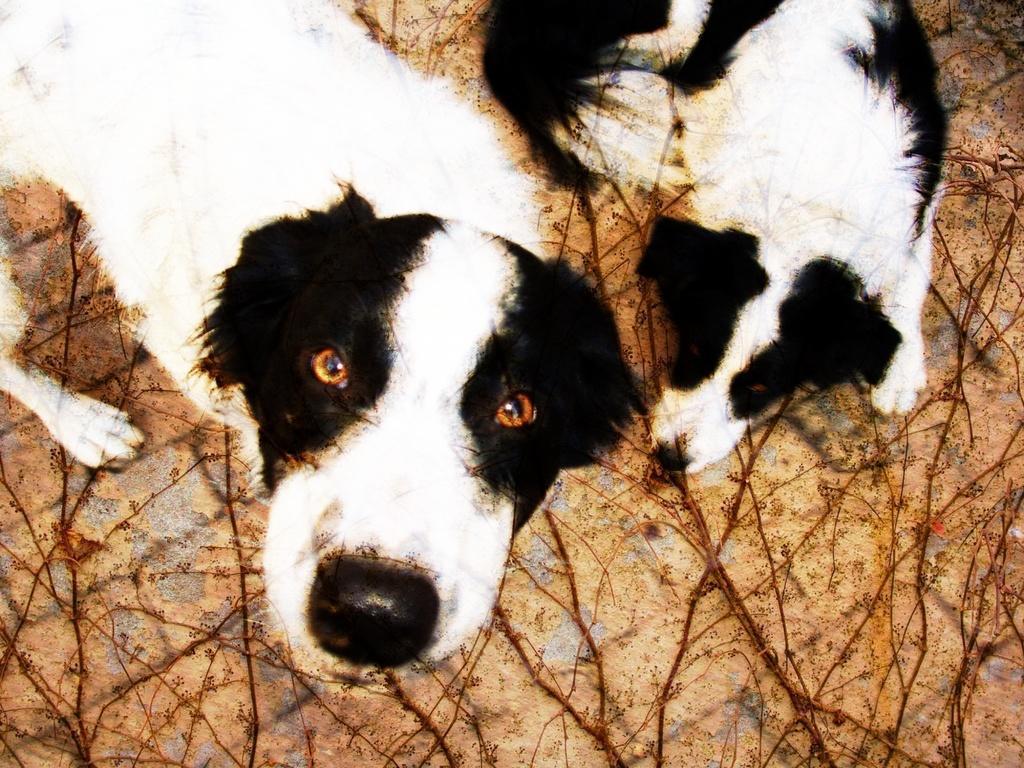In one or two sentences, can you explain what this image depicts? In this picture we can see two dogs and branches on the ground. 